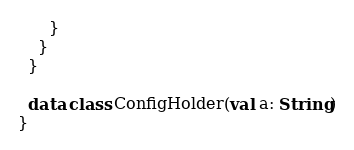<code> <loc_0><loc_0><loc_500><loc_500><_Kotlin_>      }
    }
  }

  data class ConfigHolder(val a: String)
}
</code> 